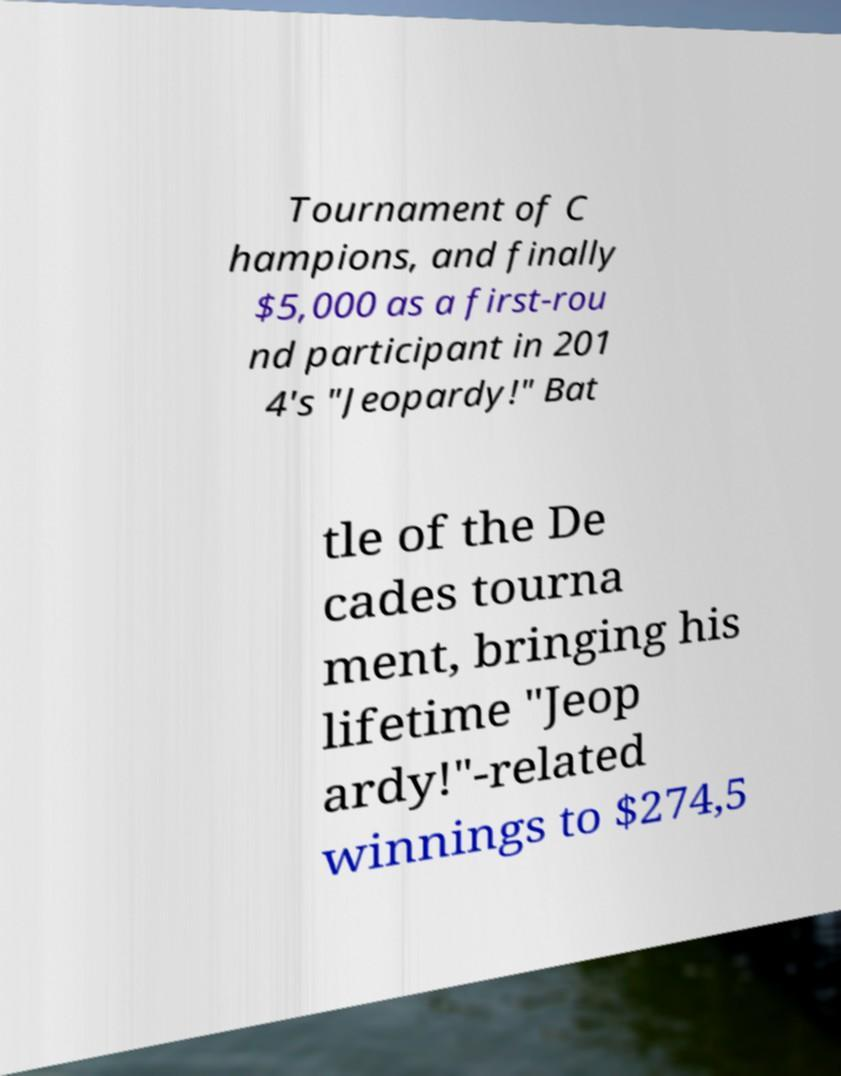Please identify and transcribe the text found in this image. Tournament of C hampions, and finally $5,000 as a first-rou nd participant in 201 4's "Jeopardy!" Bat tle of the De cades tourna ment, bringing his lifetime "Jeop ardy!"-related winnings to $274,5 